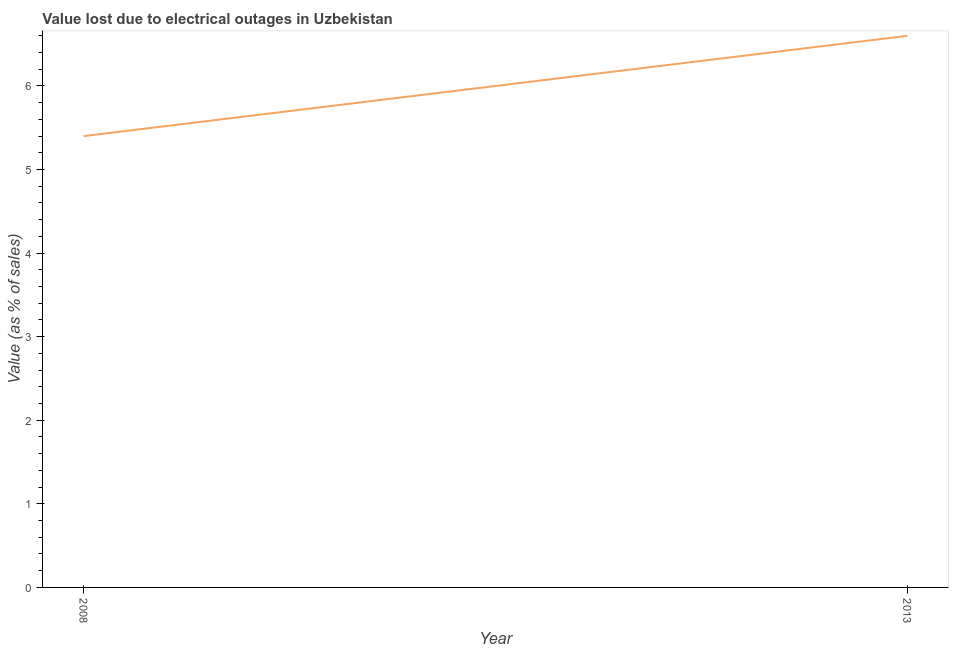Across all years, what is the maximum value lost due to electrical outages?
Offer a terse response. 6.6. In which year was the value lost due to electrical outages minimum?
Provide a short and direct response. 2008. What is the sum of the value lost due to electrical outages?
Keep it short and to the point. 12. What is the difference between the value lost due to electrical outages in 2008 and 2013?
Your answer should be compact. -1.2. What is the median value lost due to electrical outages?
Give a very brief answer. 6. What is the ratio of the value lost due to electrical outages in 2008 to that in 2013?
Offer a very short reply. 0.82. Is the value lost due to electrical outages in 2008 less than that in 2013?
Your response must be concise. Yes. In how many years, is the value lost due to electrical outages greater than the average value lost due to electrical outages taken over all years?
Offer a very short reply. 1. Does the value lost due to electrical outages monotonically increase over the years?
Offer a terse response. Yes. How many years are there in the graph?
Your response must be concise. 2. What is the difference between two consecutive major ticks on the Y-axis?
Ensure brevity in your answer.  1. Are the values on the major ticks of Y-axis written in scientific E-notation?
Provide a succinct answer. No. Does the graph contain any zero values?
Ensure brevity in your answer.  No. Does the graph contain grids?
Provide a short and direct response. No. What is the title of the graph?
Keep it short and to the point. Value lost due to electrical outages in Uzbekistan. What is the label or title of the X-axis?
Provide a short and direct response. Year. What is the label or title of the Y-axis?
Your answer should be very brief. Value (as % of sales). What is the Value (as % of sales) of 2013?
Make the answer very short. 6.6. What is the ratio of the Value (as % of sales) in 2008 to that in 2013?
Keep it short and to the point. 0.82. 